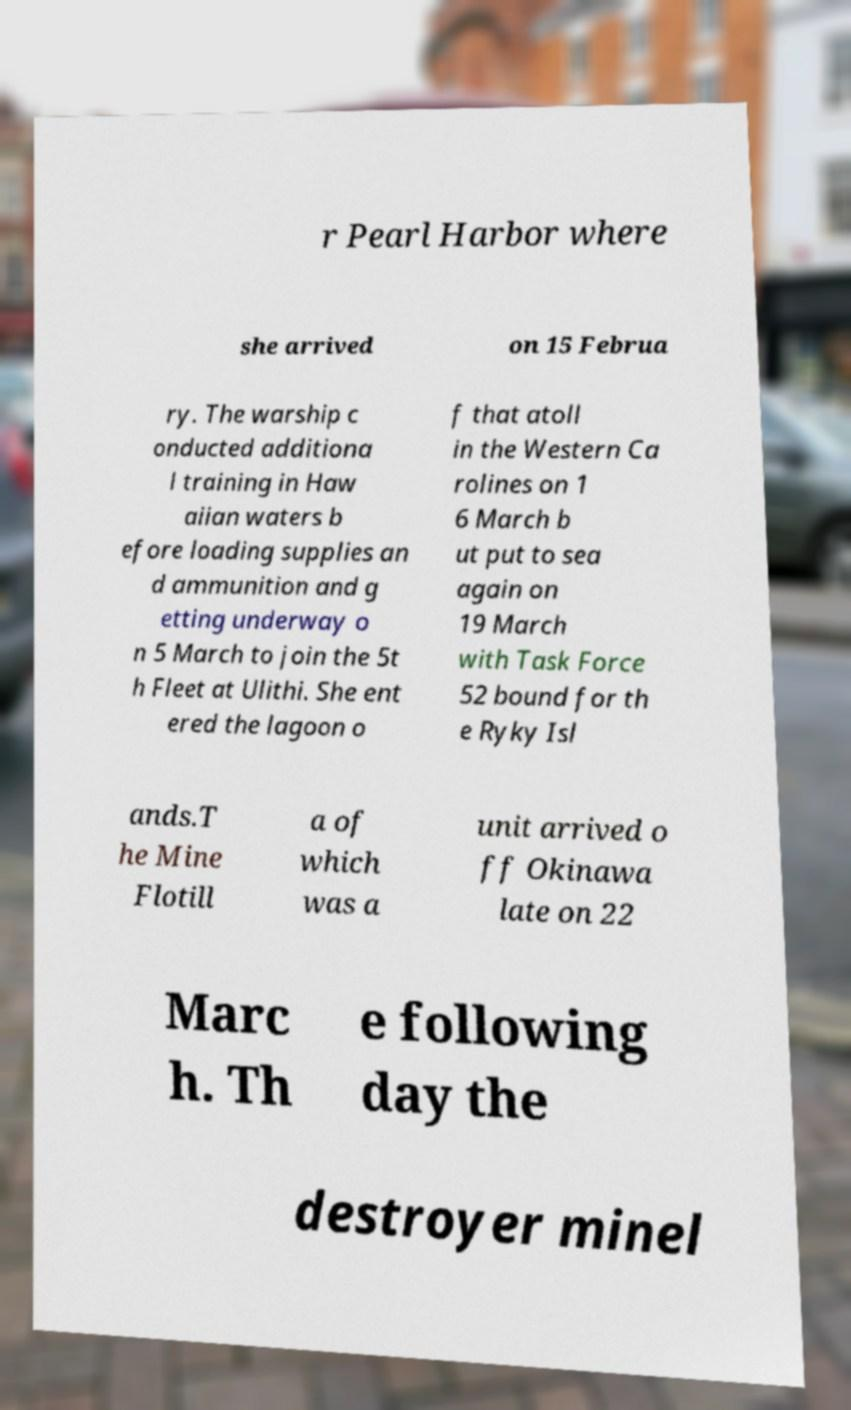I need the written content from this picture converted into text. Can you do that? r Pearl Harbor where she arrived on 15 Februa ry. The warship c onducted additiona l training in Haw aiian waters b efore loading supplies an d ammunition and g etting underway o n 5 March to join the 5t h Fleet at Ulithi. She ent ered the lagoon o f that atoll in the Western Ca rolines on 1 6 March b ut put to sea again on 19 March with Task Force 52 bound for th e Ryky Isl ands.T he Mine Flotill a of which was a unit arrived o ff Okinawa late on 22 Marc h. Th e following day the destroyer minel 